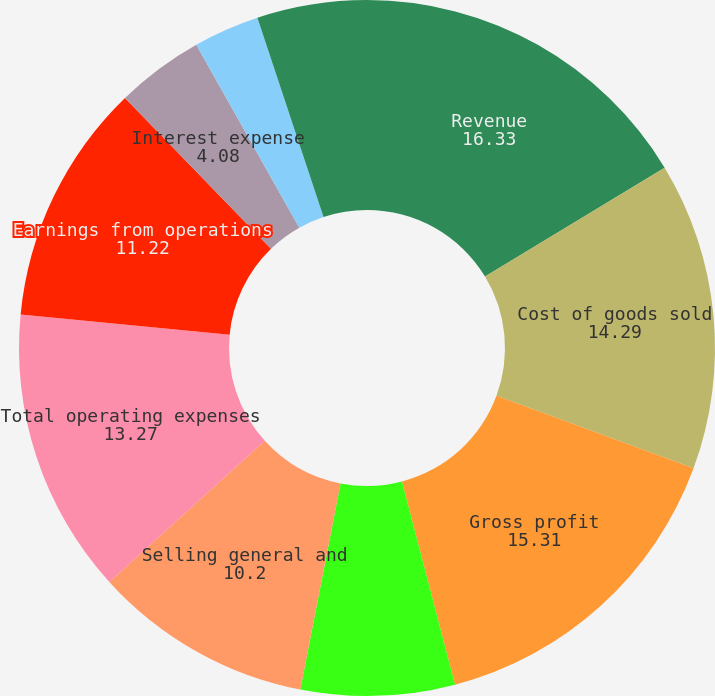<chart> <loc_0><loc_0><loc_500><loc_500><pie_chart><fcel>Revenue<fcel>Cost of goods sold<fcel>Gross profit<fcel>Research and development<fcel>Selling general and<fcel>Total operating expenses<fcel>Earnings from operations<fcel>Interest expense<fcel>Interest income<fcel>Other (income) expense net<nl><fcel>16.33%<fcel>14.29%<fcel>15.31%<fcel>7.14%<fcel>10.2%<fcel>13.27%<fcel>11.22%<fcel>4.08%<fcel>3.06%<fcel>5.1%<nl></chart> 